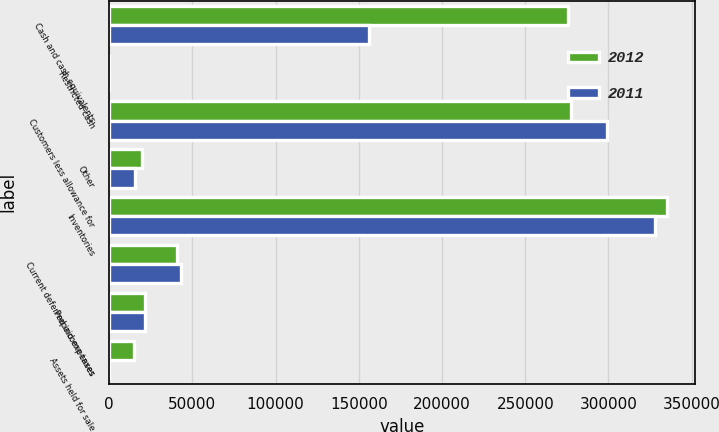Convert chart to OTSL. <chart><loc_0><loc_0><loc_500><loc_500><stacked_bar_chart><ecel><fcel>Cash and cash equivalents<fcel>Restricted cash<fcel>Customers less allowance for<fcel>Other<fcel>Inventories<fcel>Current deferred income taxes<fcel>Prepaid expenses<fcel>Assets held for sale<nl><fcel>2012<fcel>275478<fcel>0<fcel>277539<fcel>19441<fcel>335022<fcel>40696<fcel>21713<fcel>15083<nl><fcel>2011<fcel>155839<fcel>81<fcel>299166<fcel>15727<fcel>327657<fcel>43032<fcel>21598<fcel>0<nl></chart> 